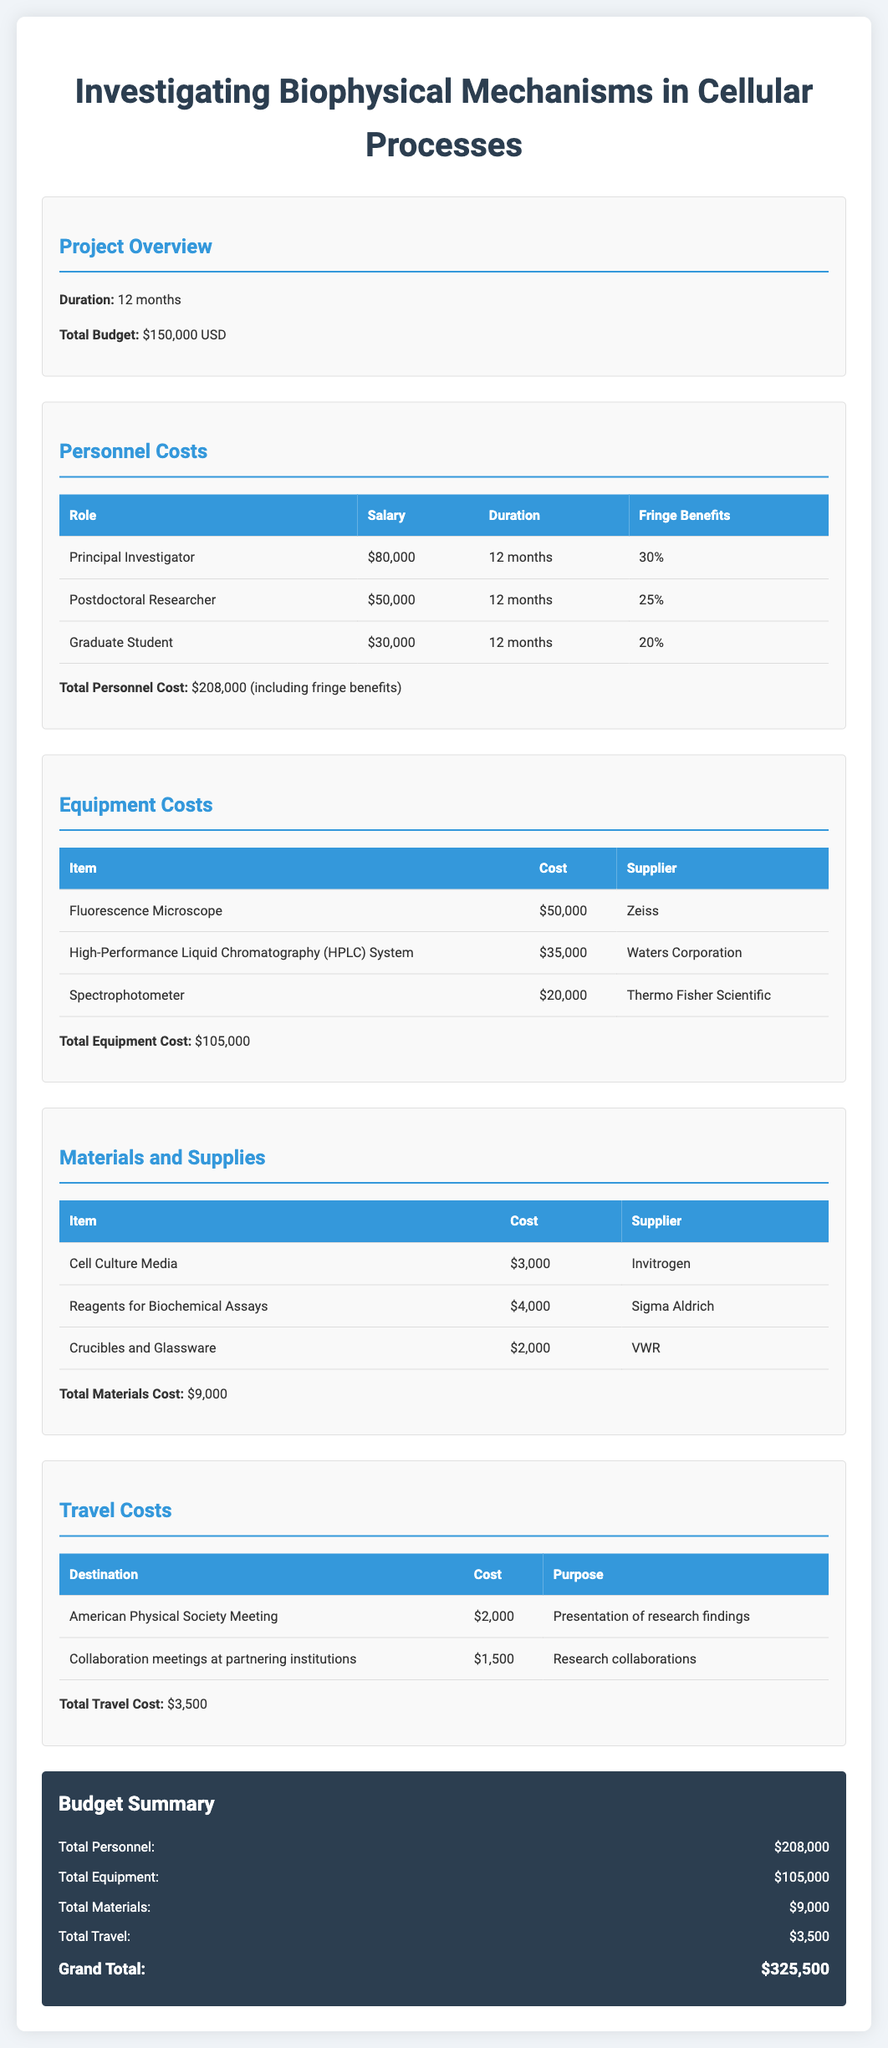what is the total budget? The total budget is stated at the beginning of the document as $150,000 USD.
Answer: $150,000 USD what is the salary of the Principal Investigator? The salary for the Principal Investigator is given in the personnel costs section as $80,000.
Answer: $80,000 what is the total personnel cost including fringe benefits? The total personnel cost, including fringe benefits, is calculated and presented as $208,000.
Answer: $208,000 how much does the Fluorescence Microscope cost? The cost of the Fluorescence Microscope is listed under equipment costs as $50,000.
Answer: $50,000 what is the purpose of the American Physical Society Meeting travel? The purpose for the travel to the American Physical Society Meeting is mentioned as "Presentation of research findings".
Answer: Presentation of research findings what is the total travel cost? The total travel cost is summarized at the end of the travel costs section as $3,500.
Answer: $3,500 what type of equipment costs the most? The equipment costs section shows the Fluorescence Microscope as the most expensive item.
Answer: Fluorescence Microscope what is the duration of the project? The duration of the project is specified in the project overview as 12 months.
Answer: 12 months how many items are listed in the Materials and Supplies section? The Materials and Supplies section contains three items listed with their respective costs.
Answer: 3 items 